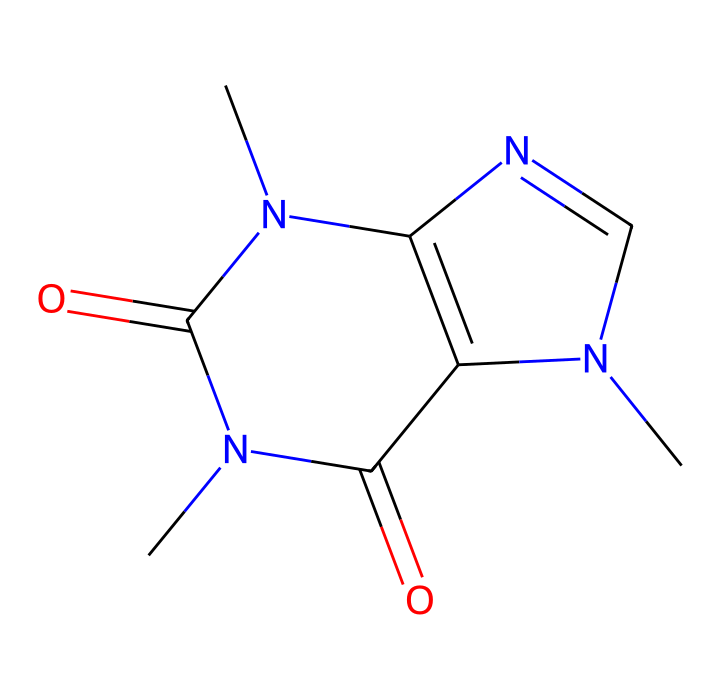what is the molecular formula for caffeine? To determine the molecular formula from the SMILES representation, count the number of carbon (C), hydrogen (H), nitrogen (N), and oxygen (O) atoms. The provided SMILES shows 8 carbon atoms, 10 hydrogen atoms, 4 nitrogen atoms, and 2 oxygen atoms. Thus, the molecular formula is C8H10N4O2.
Answer: C8H10N4O2 how many rings are present in the caffeine structure? Analyzing the chemical structure from the SMILES, there are two separate rings present in caffeine. These are the imidazole and pyrimidine rings that form part of the bicyclic system.
Answer: 2 does caffeine have geometric isomers? Caffeine does not possess geometric isomers because it lacks any double bonds that could allow for cis/trans configurations due to the absence of restricted rotation in the structure.
Answer: no what kind of isomerism can occur with caffeine? Caffeine features structural isomerism due to the various possible arrangements of atoms, leading to different molecules with the same molecular formula but different connectivity.
Answer: structural isomerism which elements primarily contribute to the hydrogen bonding in caffeine? The nitrogen atoms in caffeine can form hydrogen bonds due to the presence of lone pairs and their electronegativity. This is central to its interaction in biological systems.
Answer: nitrogen how many nitrogen atoms are in the caffeine molecule? By checking the SMILES representation, we can see that there are four nitrogen atoms represented, confirming the composition of caffeine.
Answer: 4 what type of chemical is caffeine classified as based on its structure? Caffeine is classified as a xanthine alkaloid, characterized by its nitrogen-containing aromatic structure that is common in many plant-derived substances.
Answer: xanthine alkaloid 